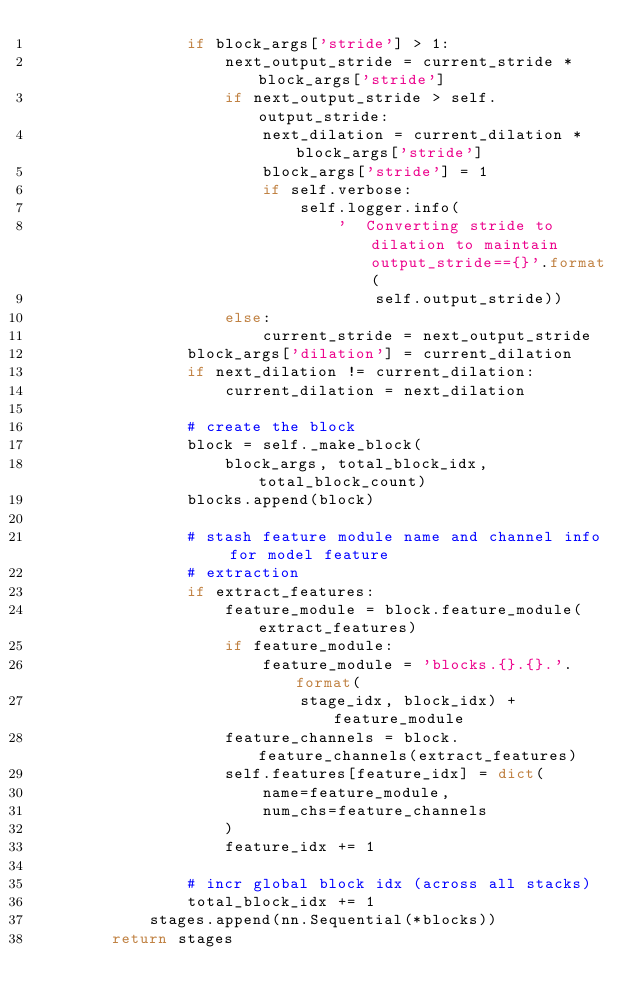<code> <loc_0><loc_0><loc_500><loc_500><_Python_>                if block_args['stride'] > 1:
                    next_output_stride = current_stride * block_args['stride']
                    if next_output_stride > self.output_stride:
                        next_dilation = current_dilation * block_args['stride']
                        block_args['stride'] = 1
                        if self.verbose:
                            self.logger.info(
                                '  Converting stride to dilation to maintain output_stride=={}'.format(
                                    self.output_stride))
                    else:
                        current_stride = next_output_stride
                block_args['dilation'] = current_dilation
                if next_dilation != current_dilation:
                    current_dilation = next_dilation

                # create the block
                block = self._make_block(
                    block_args, total_block_idx, total_block_count)
                blocks.append(block)

                # stash feature module name and channel info for model feature
                # extraction
                if extract_features:
                    feature_module = block.feature_module(extract_features)
                    if feature_module:
                        feature_module = 'blocks.{}.{}.'.format(
                            stage_idx, block_idx) + feature_module
                    feature_channels = block.feature_channels(extract_features)
                    self.features[feature_idx] = dict(
                        name=feature_module,
                        num_chs=feature_channels
                    )
                    feature_idx += 1

                # incr global block idx (across all stacks)
                total_block_idx += 1
            stages.append(nn.Sequential(*blocks))
        return stages
</code> 